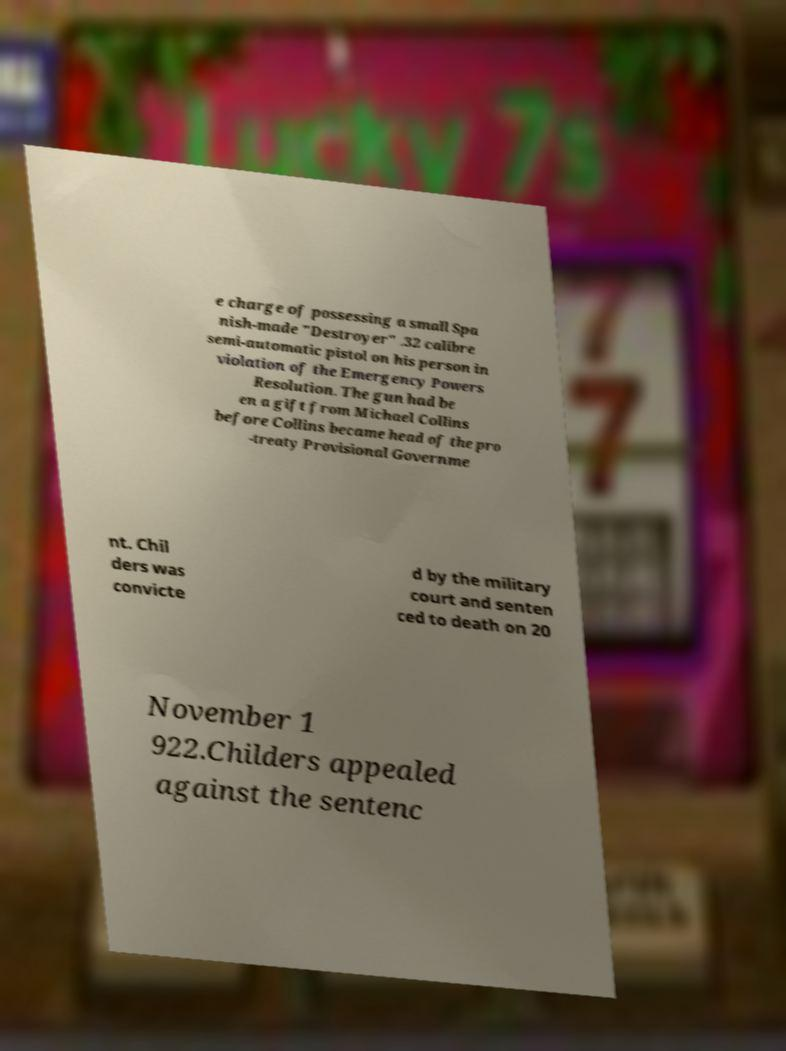I need the written content from this picture converted into text. Can you do that? e charge of possessing a small Spa nish-made "Destroyer" .32 calibre semi-automatic pistol on his person in violation of the Emergency Powers Resolution. The gun had be en a gift from Michael Collins before Collins became head of the pro -treaty Provisional Governme nt. Chil ders was convicte d by the military court and senten ced to death on 20 November 1 922.Childers appealed against the sentenc 